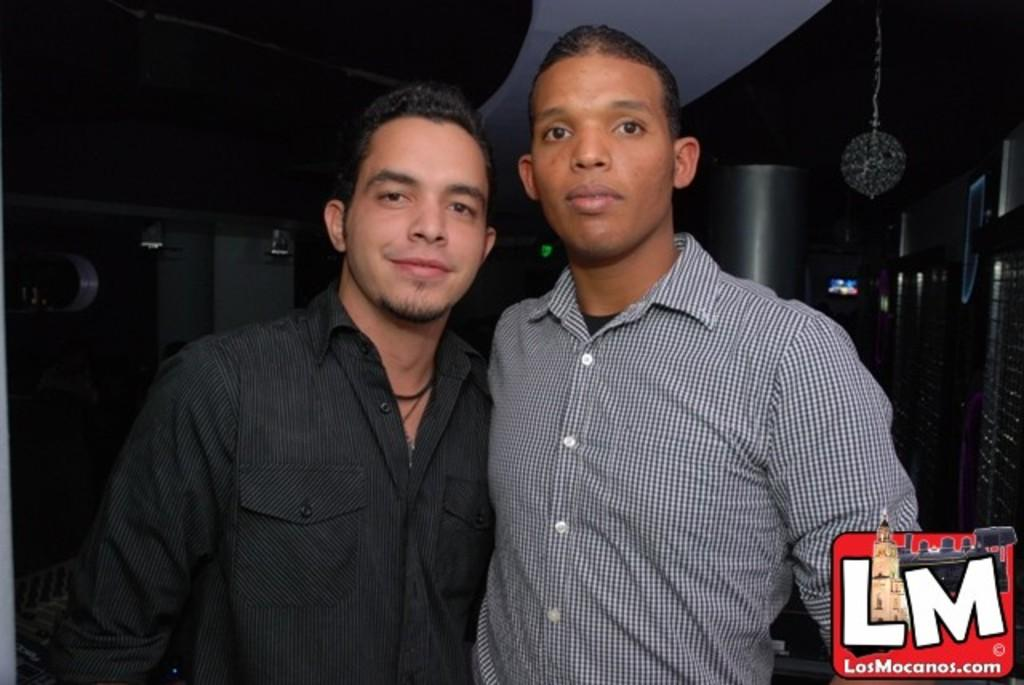How many people are in the foreground of the picture? There are two men standing in the foreground of the picture. What can be observed about the background of the image? The background of the image is dark. What is present on the right side of the image? There are objects on the right side of the image. Where is the logo located in the image? The logo is at the bottom towards the right side of the image. What type of joke is the goose telling in the image? There is no goose present in the image, and therefore no joke can be observed. What is the moon's role in the image? The moon is not present in the image, so it does not have a role. 